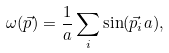Convert formula to latex. <formula><loc_0><loc_0><loc_500><loc_500>\omega ( \vec { p } ) = { \frac { 1 } { a } } \sum _ { i } \sin ( \vec { p } _ { i } a ) ,</formula> 